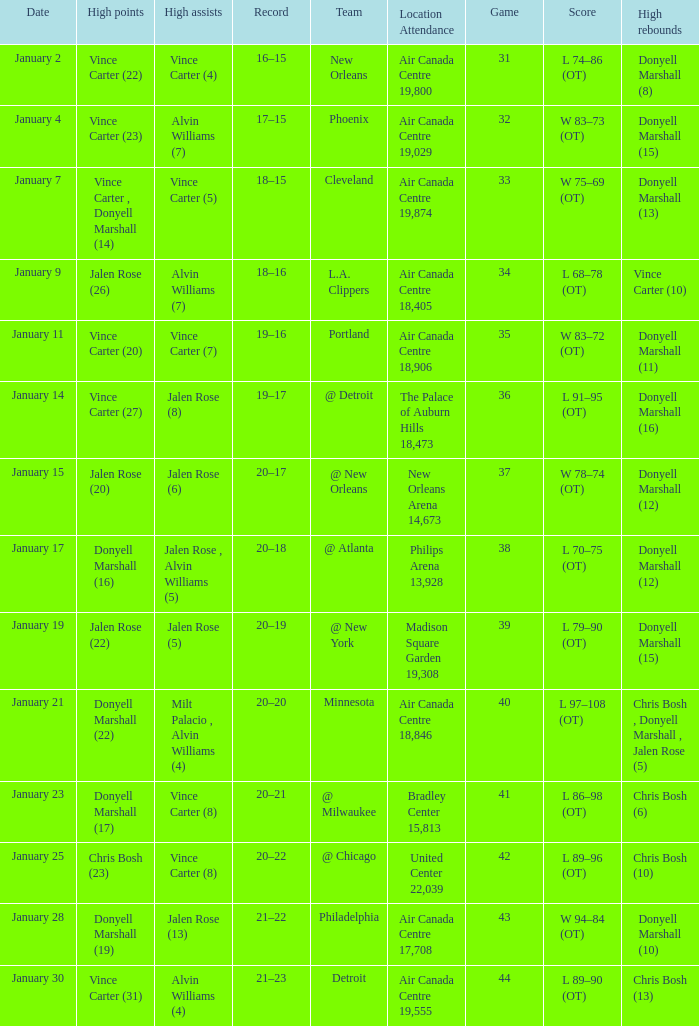Where was the game, and how many attended the game on january 2? Air Canada Centre 19,800. 